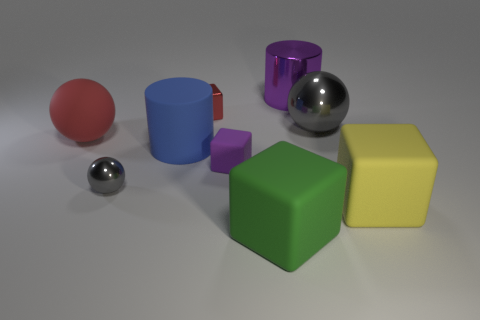Is the number of cylinders that are in front of the blue cylinder the same as the number of blocks that are to the left of the large green cube?
Offer a terse response. No. What number of objects are either balls behind the small purple thing or big objects that are to the left of the purple cylinder?
Offer a terse response. 4. There is a object that is both on the left side of the large green rubber thing and behind the big red sphere; what is its material?
Ensure brevity in your answer.  Metal. What is the size of the shiny sphere that is behind the metal thing to the left of the tiny block that is to the left of the small purple rubber block?
Give a very brief answer. Large. Are there more large gray balls than big cylinders?
Keep it short and to the point. No. Do the sphere that is on the right side of the large blue object and the large blue cylinder have the same material?
Provide a short and direct response. No. Is the number of gray matte objects less than the number of small things?
Provide a short and direct response. Yes. There is a large matte object that is right of the purple object to the right of the small purple matte thing; are there any tiny gray shiny things that are right of it?
Provide a succinct answer. No. Does the object that is in front of the large yellow rubber block have the same shape as the tiny rubber thing?
Your response must be concise. Yes. Are there more shiny blocks that are behind the yellow cube than brown metallic objects?
Provide a succinct answer. Yes. 